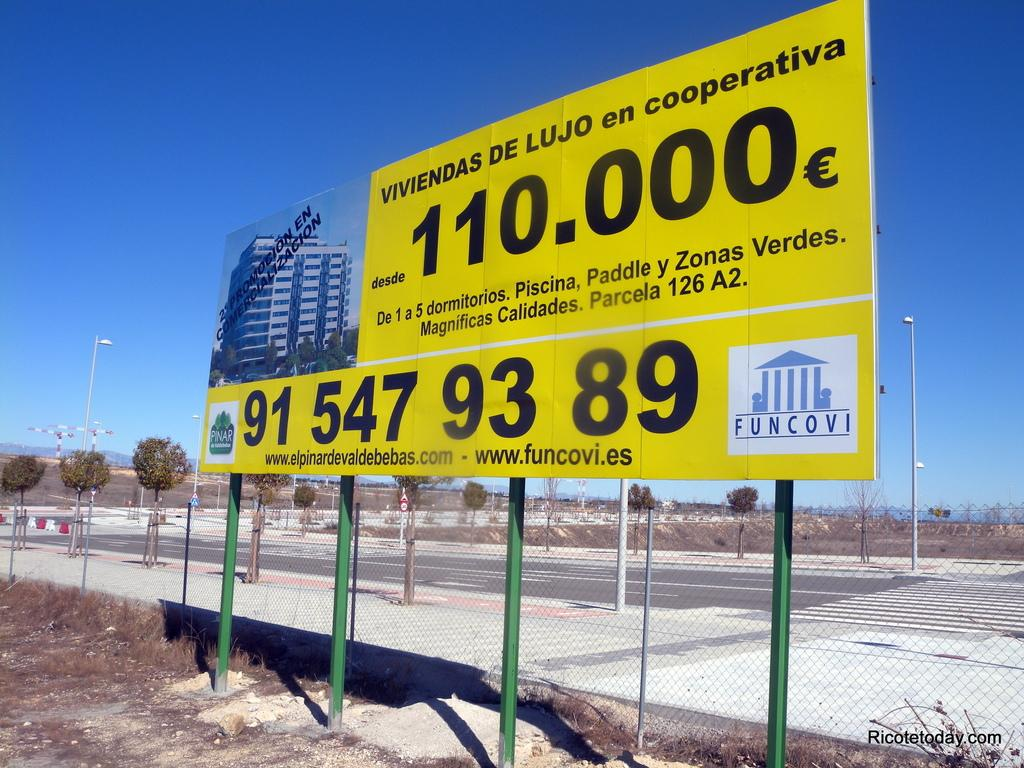<image>
Describe the image concisely. A sign advertising Viviendas de Lujo for 100.000 euros. 